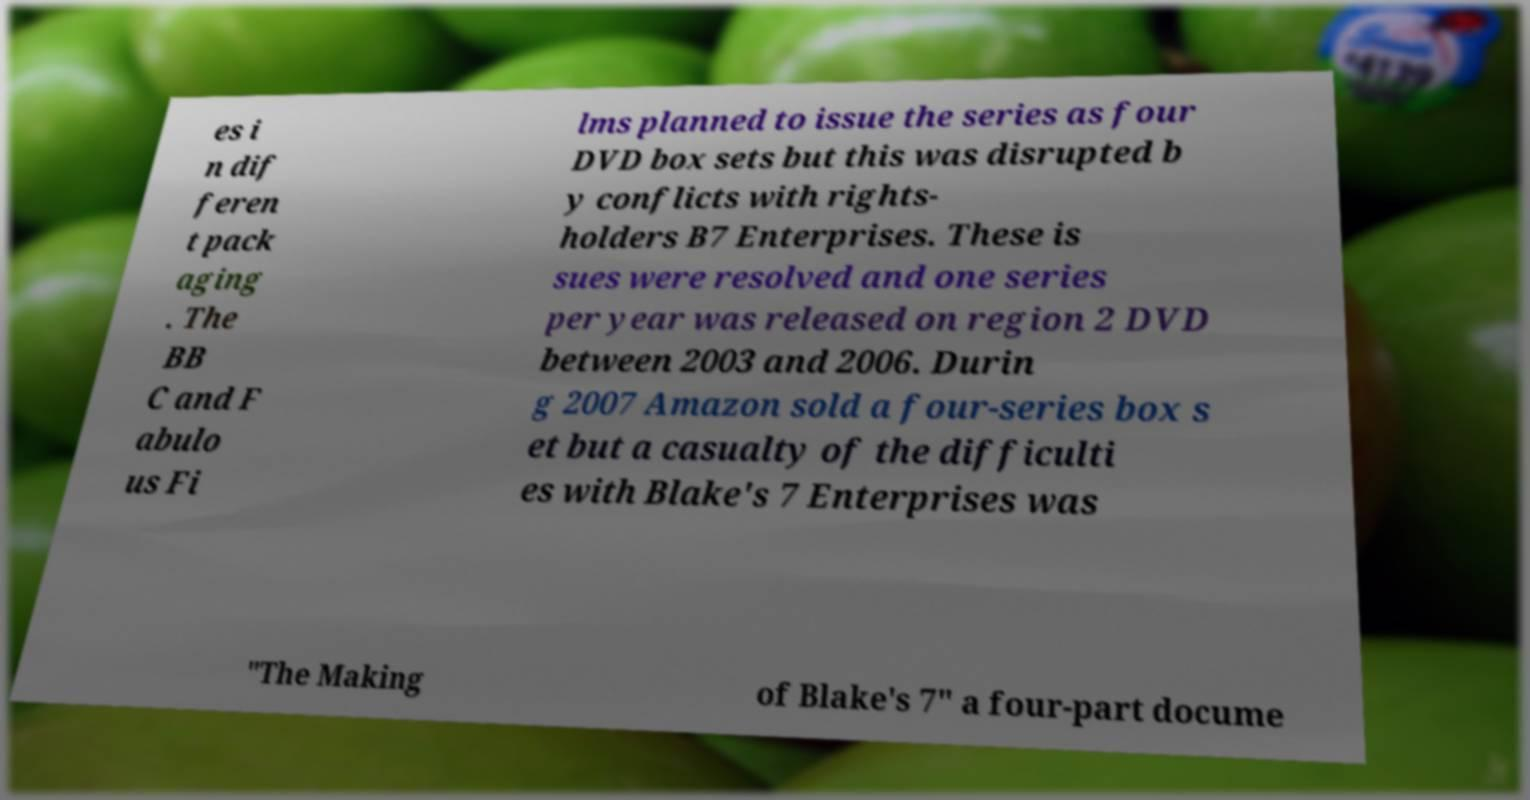Please read and relay the text visible in this image. What does it say? es i n dif feren t pack aging . The BB C and F abulo us Fi lms planned to issue the series as four DVD box sets but this was disrupted b y conflicts with rights- holders B7 Enterprises. These is sues were resolved and one series per year was released on region 2 DVD between 2003 and 2006. Durin g 2007 Amazon sold a four-series box s et but a casualty of the difficulti es with Blake's 7 Enterprises was "The Making of Blake's 7" a four-part docume 